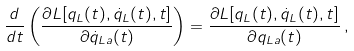<formula> <loc_0><loc_0><loc_500><loc_500>\frac { d } { d t } \left ( \frac { \partial L [ q _ { L } ( t ) , \dot { q } _ { L } ( t ) , t ] } { \partial \dot { q } _ { L a } ( t ) } \right ) = \frac { \partial L [ q _ { L } ( t ) , \dot { q } _ { L } ( t ) , t ] } { \partial q _ { L a } ( t ) } \, ,</formula> 